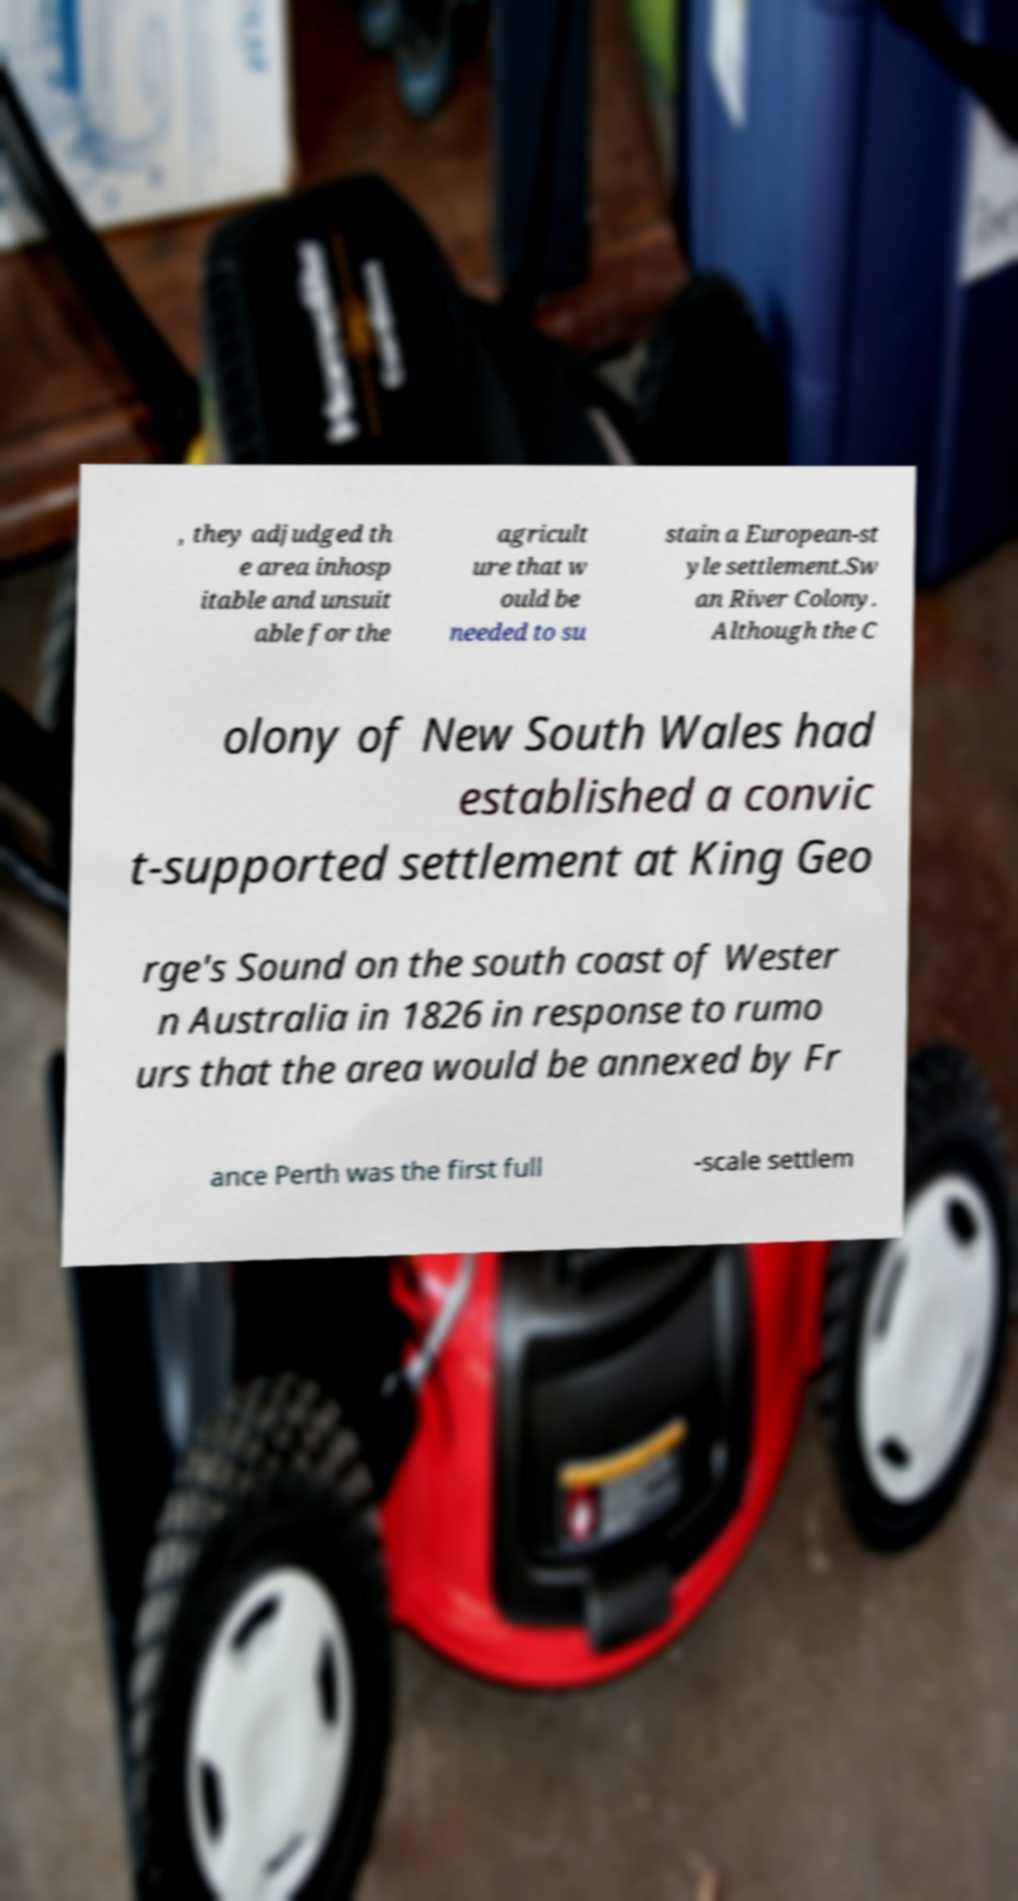Please read and relay the text visible in this image. What does it say? , they adjudged th e area inhosp itable and unsuit able for the agricult ure that w ould be needed to su stain a European-st yle settlement.Sw an River Colony. Although the C olony of New South Wales had established a convic t-supported settlement at King Geo rge's Sound on the south coast of Wester n Australia in 1826 in response to rumo urs that the area would be annexed by Fr ance Perth was the first full -scale settlem 